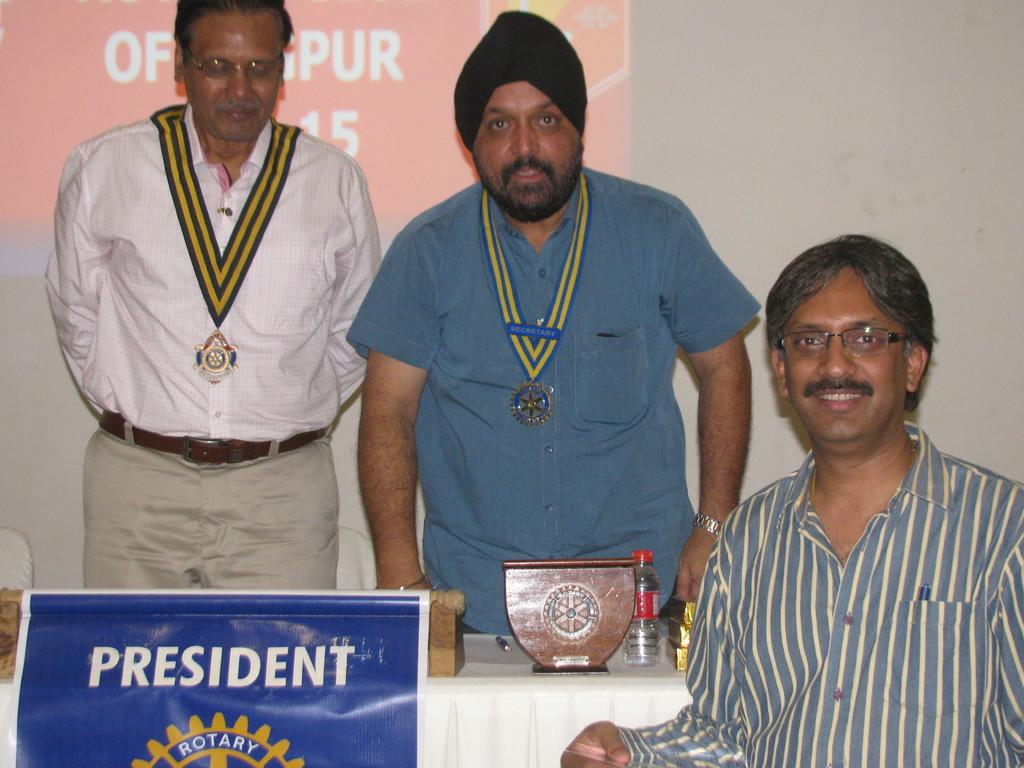<image>
Write a terse but informative summary of the picture. Two men stand while one sits behind a sign stating President. 